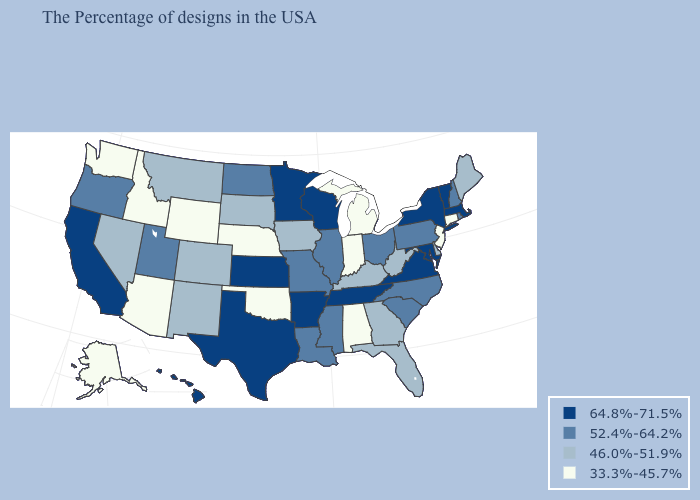Name the states that have a value in the range 33.3%-45.7%?
Quick response, please. Connecticut, New Jersey, Michigan, Indiana, Alabama, Nebraska, Oklahoma, Wyoming, Arizona, Idaho, Washington, Alaska. What is the value of Oregon?
Give a very brief answer. 52.4%-64.2%. Does the map have missing data?
Be succinct. No. Which states have the lowest value in the USA?
Quick response, please. Connecticut, New Jersey, Michigan, Indiana, Alabama, Nebraska, Oklahoma, Wyoming, Arizona, Idaho, Washington, Alaska. What is the highest value in the West ?
Answer briefly. 64.8%-71.5%. Does Wyoming have the same value as Idaho?
Keep it brief. Yes. Name the states that have a value in the range 33.3%-45.7%?
Short answer required. Connecticut, New Jersey, Michigan, Indiana, Alabama, Nebraska, Oklahoma, Wyoming, Arizona, Idaho, Washington, Alaska. What is the highest value in the USA?
Concise answer only. 64.8%-71.5%. Among the states that border Maine , which have the lowest value?
Keep it brief. New Hampshire. Does New Jersey have a lower value than Idaho?
Write a very short answer. No. What is the highest value in the USA?
Concise answer only. 64.8%-71.5%. Name the states that have a value in the range 52.4%-64.2%?
Quick response, please. Rhode Island, New Hampshire, Pennsylvania, North Carolina, South Carolina, Ohio, Illinois, Mississippi, Louisiana, Missouri, North Dakota, Utah, Oregon. Name the states that have a value in the range 64.8%-71.5%?
Concise answer only. Massachusetts, Vermont, New York, Maryland, Virginia, Tennessee, Wisconsin, Arkansas, Minnesota, Kansas, Texas, California, Hawaii. What is the highest value in states that border Delaware?
Answer briefly. 64.8%-71.5%. What is the value of New Mexico?
Keep it brief. 46.0%-51.9%. 